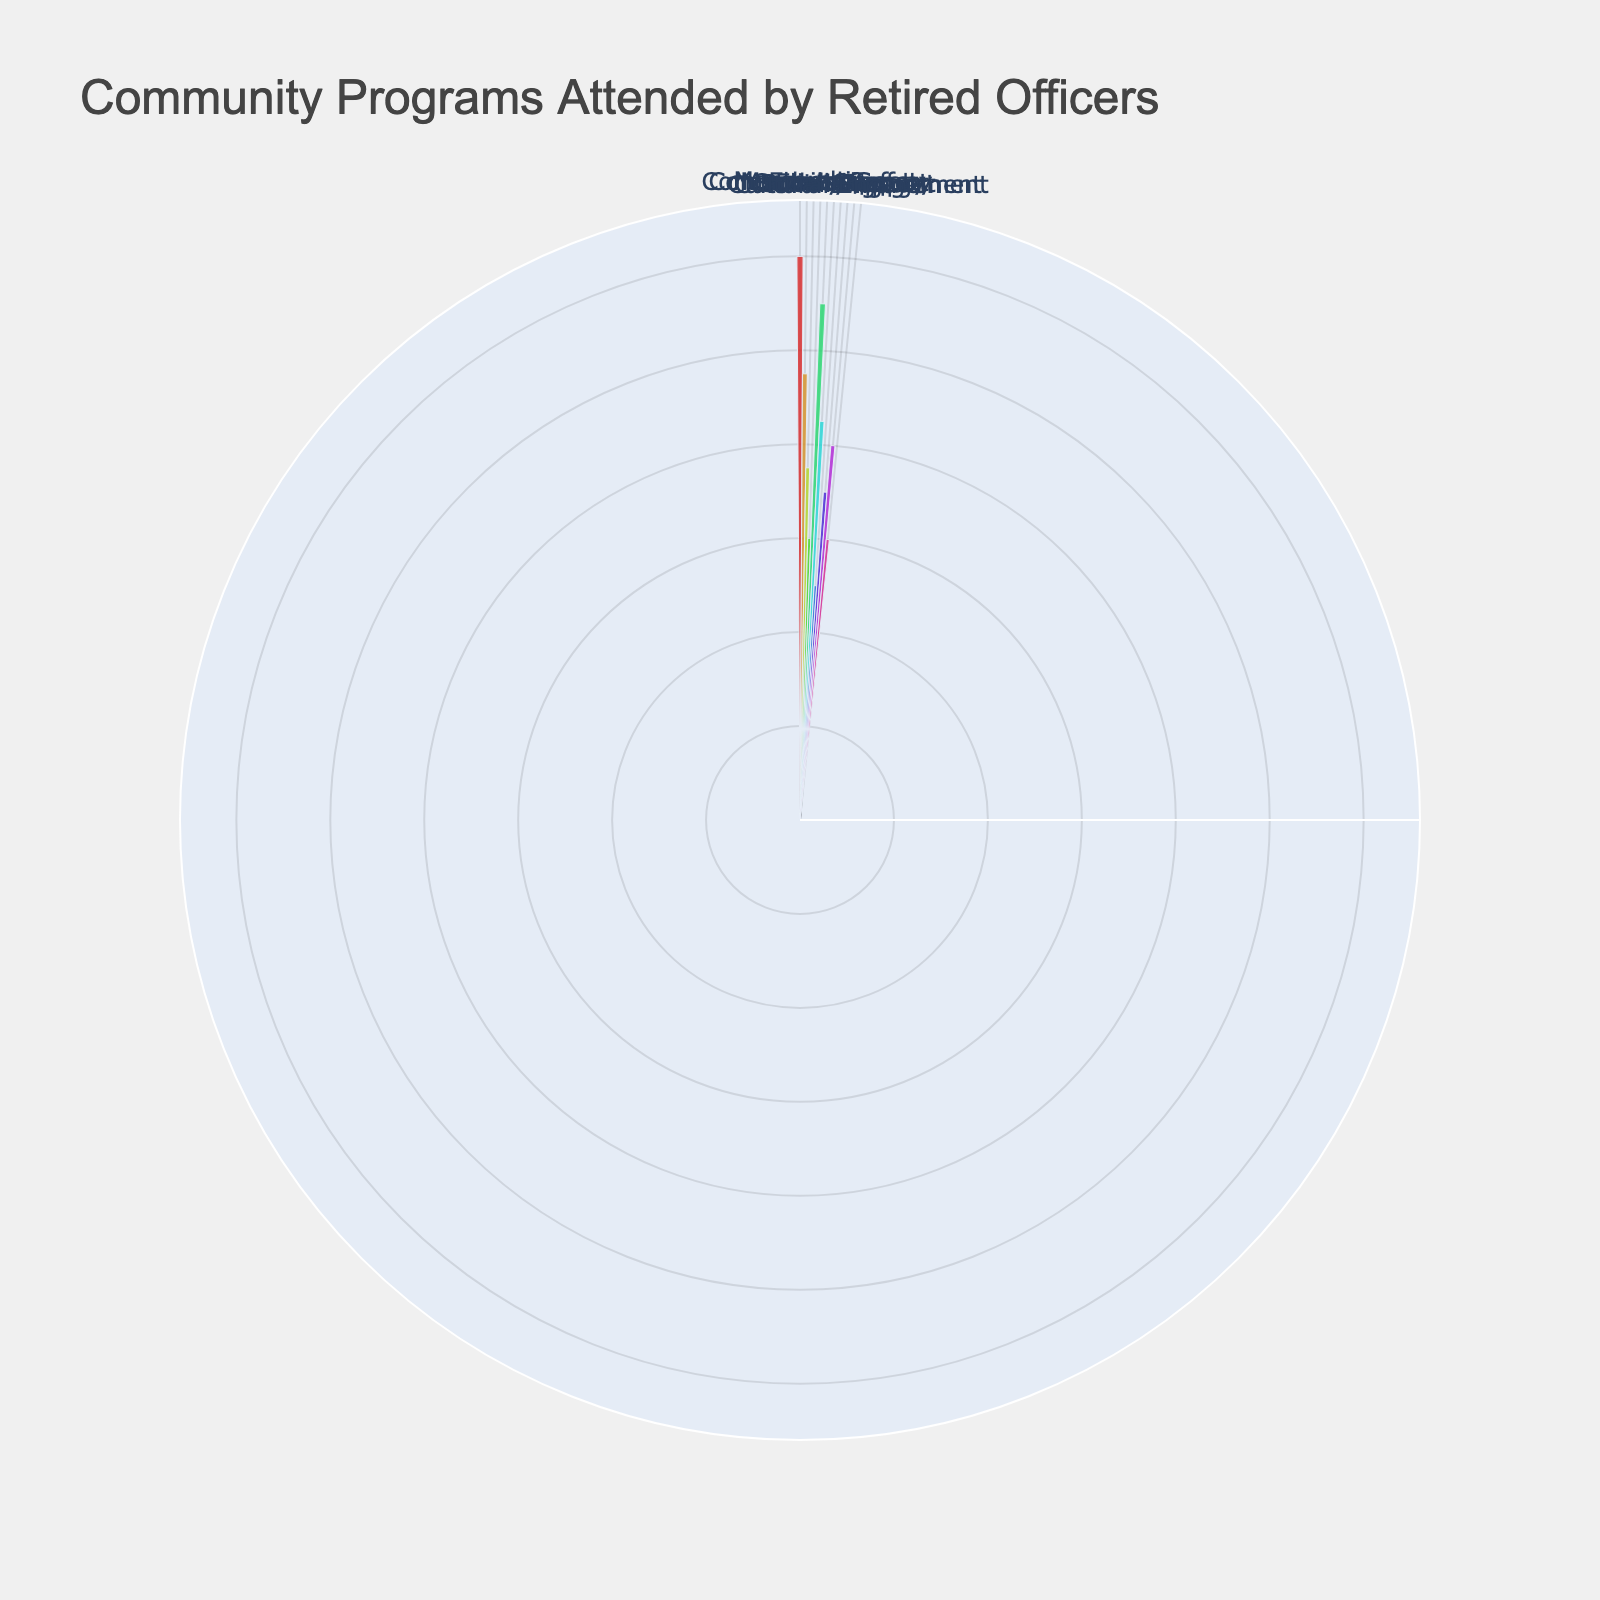How many categories of community programs are shown in the rose chart? The rose chart has specific angular ticks representing different categories. By counting each unique category label, we can determine the number of categories in the chart.
Answer: 5 Which program has the highest attendance? By looking at the lengths of the bars in the rose chart, the program with the longest bar has the highest attendance.
Answer: Autobadge Youth Academy What is the combined attendance for Community Safety programs? The Community Safety category includes Neighborhood Watch Meetings and Citizens Police Academy. Adding their attendance numbers, 75 and 60 respectively, gives the combined attendance.
Answer: 135 Is the attendance of Language Exchange Programs higher or lower than Crime Prevention Workshops? Comparing the lengths of the bars for Language Exchange Programs and Crime Prevention Workshops, we can see which one is higher.
Answer: Lower What is the average attendance for programs in the Cultural Engagement category? The Cultural Engagement category includes Hispanic Heritage Celebrations and Language Exchange Programs. Summing their attendance (80 + 60) and dividing by the number of programs (2) gives the average.
Answer: 70 Which category has the smallest combined attendance, and what is that total? To determine the category with the smallest combined attendance, we need to sum the attendance for all programs within each category and compare these totals. The smallest combined total belongs to the category with the least sum.
Answer: Social Support, 120 How does attendance for Police Explorers compare to Officer Wellness Initiatives? By comparing the lengths of the bars for Police Explorers and Officer Wellness Initiatives, we can determine which has greater attendance.
Answer: Higher What is the attendance difference between the Education and Social Support categories? Sum the attendance figures for both Education programs (110 + 85) and Social Support programs (50 + 70). Subtract the smaller total from the larger one to find the difference.
Answer: 75 Which program in the Mentorship category has the lowest attendance? By comparing the attendance figures of all programs within the Mentorship category, the one with the lowest number will be identified.
Answer: Police Explorers Is there a significant difference in attendance between the categories with the highest and lowest combined attendance? Sum the attendance in each category, identify the highest and lowest totals, and calculate their difference to see if it is significant.
Answer: Yes 